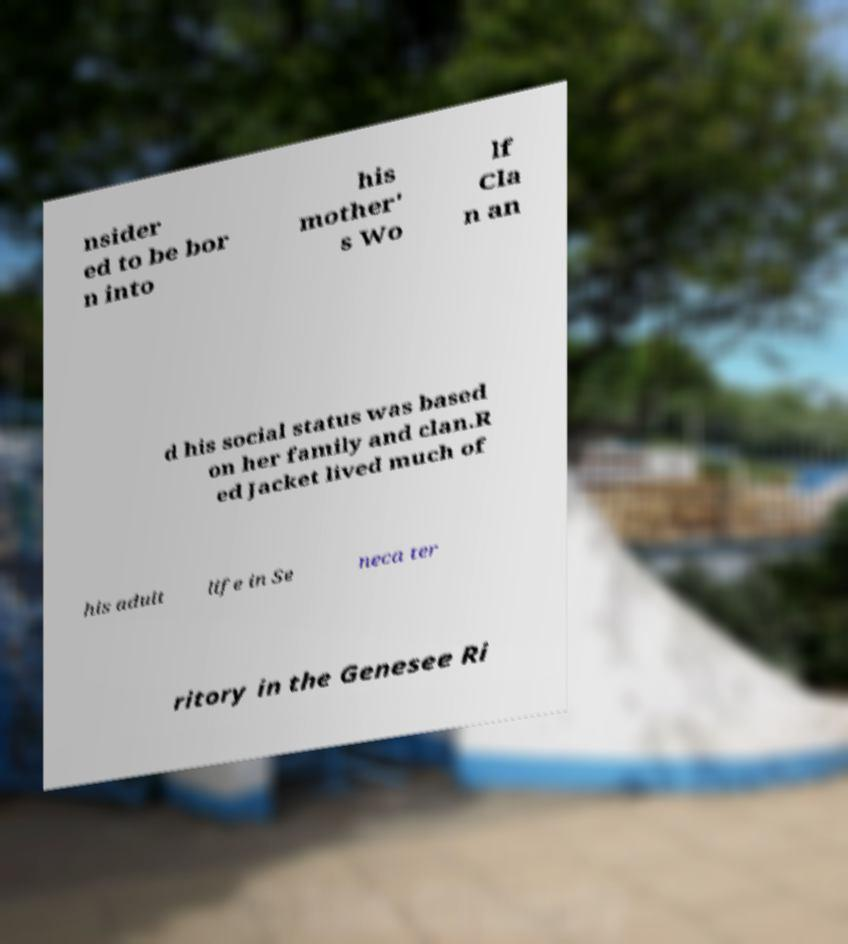I need the written content from this picture converted into text. Can you do that? nsider ed to be bor n into his mother' s Wo lf Cla n an d his social status was based on her family and clan.R ed Jacket lived much of his adult life in Se neca ter ritory in the Genesee Ri 